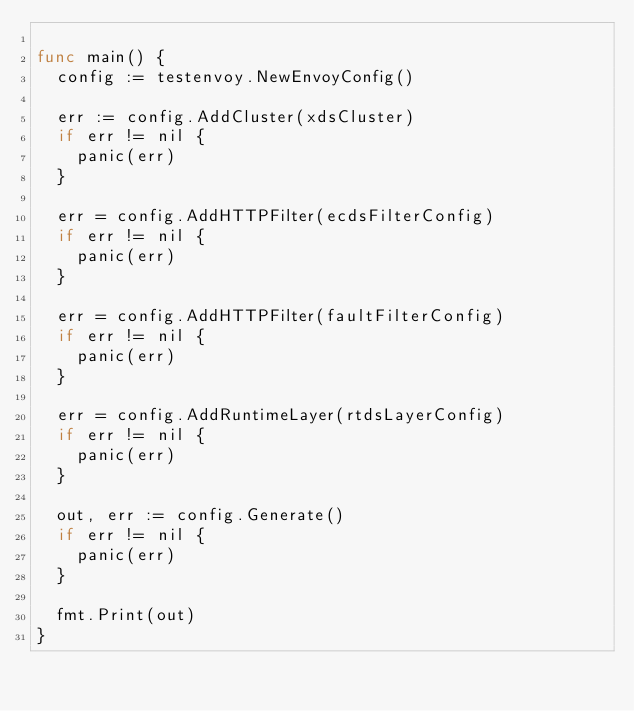Convert code to text. <code><loc_0><loc_0><loc_500><loc_500><_Go_>
func main() {
	config := testenvoy.NewEnvoyConfig()

	err := config.AddCluster(xdsCluster)
	if err != nil {
		panic(err)
	}

	err = config.AddHTTPFilter(ecdsFilterConfig)
	if err != nil {
		panic(err)
	}

	err = config.AddHTTPFilter(faultFilterConfig)
	if err != nil {
		panic(err)
	}

	err = config.AddRuntimeLayer(rtdsLayerConfig)
	if err != nil {
		panic(err)
	}

	out, err := config.Generate()
	if err != nil {
		panic(err)
	}

	fmt.Print(out)
}
</code> 